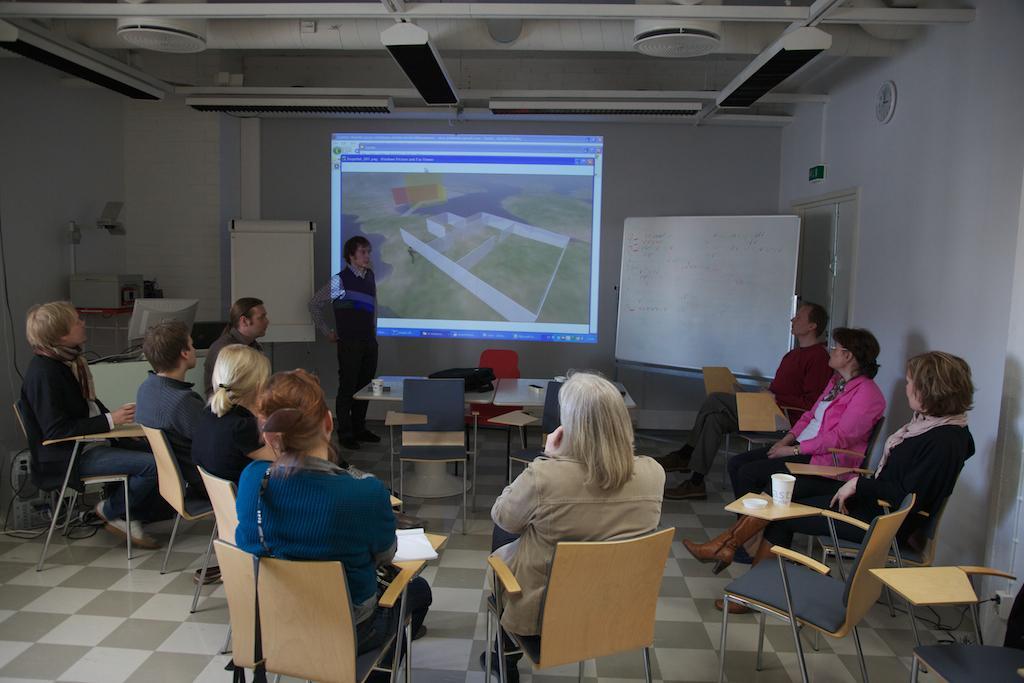Could you give a brief overview of what you see in this image? In this image we can see a few people sitting on the chairs which are on the floor. We can also see the book, cups, tables, bag and also empty chairs. In the background we can see the projector screen, boards, a monitor and also a person standing. At the top there is ceiling. We can see the wall clock and also the door on the right. 